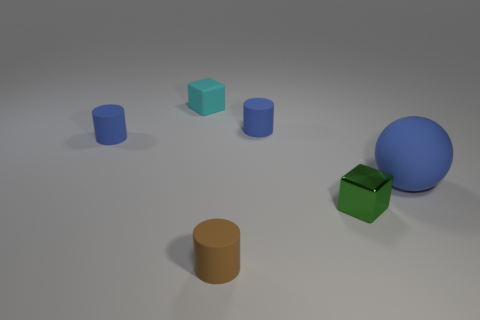Subtract all blue cylinders. How many cylinders are left? 1 Add 3 large blue metallic things. How many objects exist? 9 Subtract all green blocks. How many blocks are left? 1 Subtract all balls. How many objects are left? 5 Subtract all gray blocks. Subtract all cyan spheres. How many blocks are left? 2 Subtract all red cylinders. How many green cubes are left? 1 Subtract all cyan cubes. Subtract all large green matte balls. How many objects are left? 5 Add 3 matte cylinders. How many matte cylinders are left? 6 Add 2 large gray matte cubes. How many large gray matte cubes exist? 2 Subtract 0 gray balls. How many objects are left? 6 